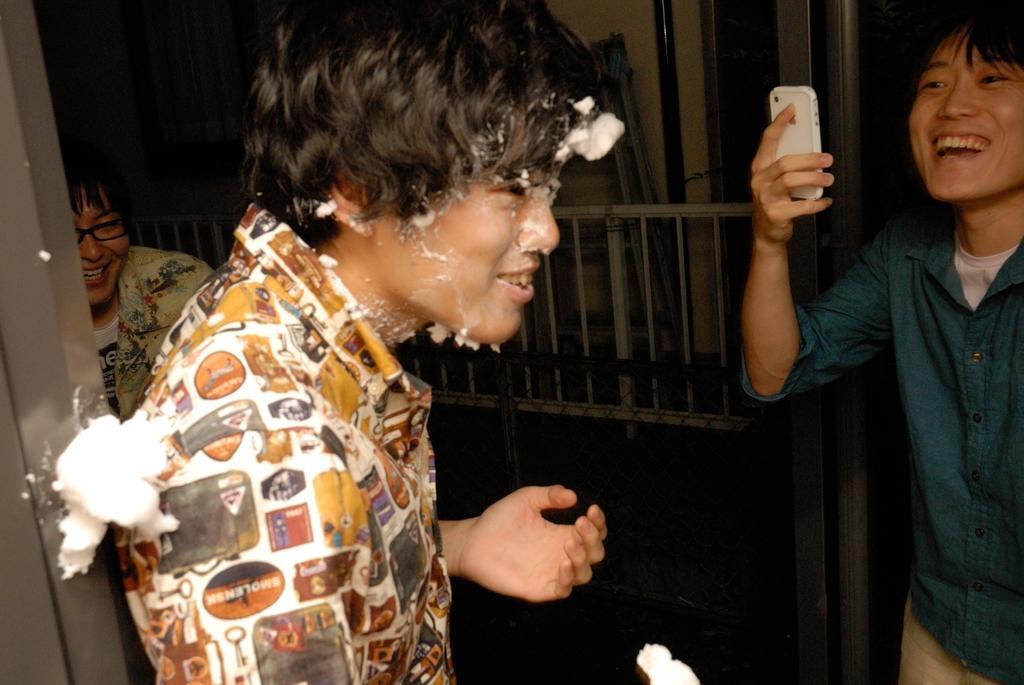Please provide a concise description of this image. In this picture we can observe three men. All of them were smiling. On the left side there is a man wearing spectacles. We can observe a railing. On the right side there is a man taking photograph with a mobile in his hand. 